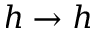<formula> <loc_0><loc_0><loc_500><loc_500>h \rightarrow h</formula> 